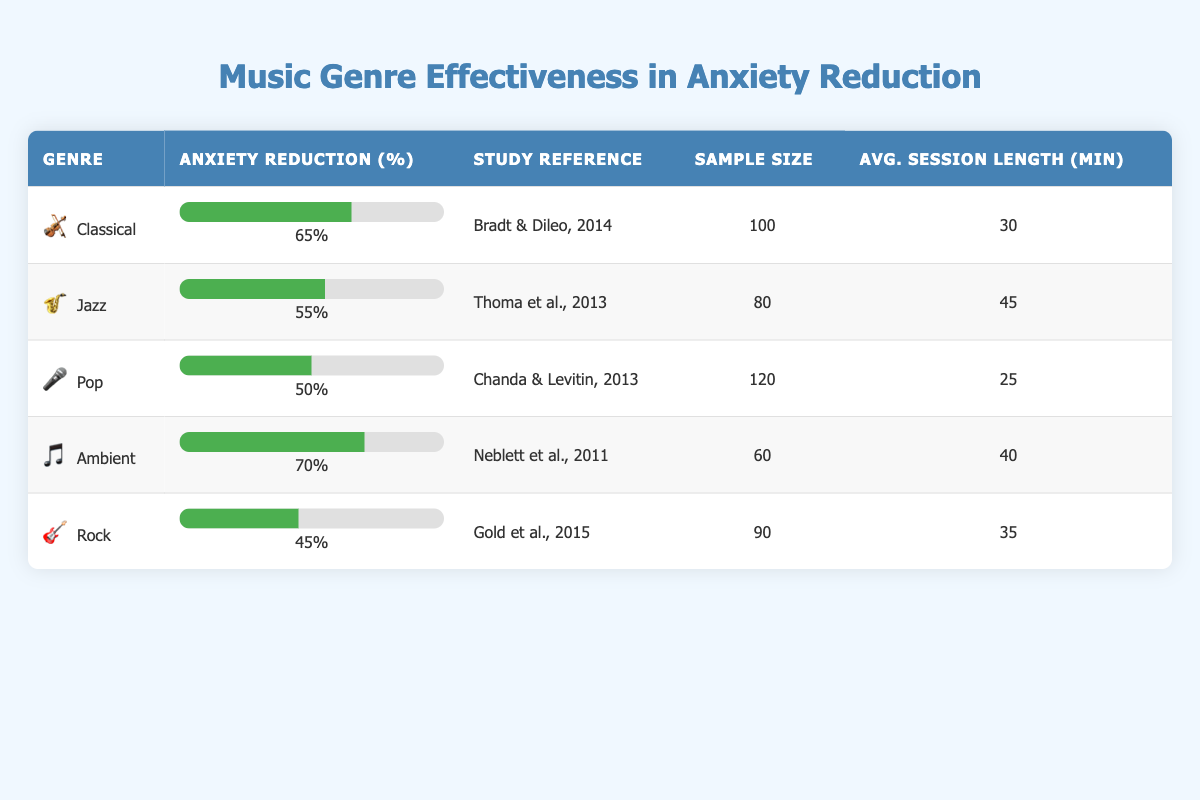What is the anxiety reduction percentage for Classical music? The table shows the anxiety reduction percentage for Classical music as 65%. Simply look for the row corresponding to Classical in the table.
Answer: 65% Which music genre has the highest anxiety reduction percentage? By comparing the anxiety reduction percentages in the table, Ambient music has the highest percentage at 70%. This is determined by scanning the percentages for all music genres listed.
Answer: Ambient What is the average session length for Jazz music therapy? The table indicates that the average session length for Jazz music therapy is 45 minutes. This value is found directly in the row for Jazz.
Answer: 45 minutes Is the sample size for Pop music therapy greater than that for Rock music therapy? The sample size for Pop music therapy is 120, while for Rock it's 90. Therefore, comparing these numbers shows that Pop's sample size is greater than Rock's.
Answer: Yes What is the average anxiety reduction percentage for the top two genres? The top two genres by anxiety reduction are Ambient (70%) and Classical (65%). The average is calculated by adding the two percentages (70 + 65) = 135, and then dividing by 2 to get 67.5. The steps are to identify the top two genres, sum their percentages, and divide by 2.
Answer: 67.5% Which genre has the lowest anxiety reduction percentage, and what is that percentage? From the data, Rock music has the lowest anxiety reduction percentage of 45%. This is identified by checking the percentages listed and finding the minimum value.
Answer: Rock, 45% How many more patients were involved in the Pop study compared to the Ambient study? The sample size for Pop is 120, and for Ambient, it is 60. The difference is calculated as 120 - 60 = 60, indicating there were 60 more patients in the Pop study. The answer involves subtracting the sample sizes.
Answer: 60 Is it true that Anxiety reduction percentage for Jazz is more than that for Rock? The anxiety reduction for Jazz is 55%, while for Rock it is 45%. Thus, confirming that 55 is greater than 45, shows that the statement is true. This is a straightforward comparison.
Answer: Yes What is the total sample size of all five music genres studied? The individual sample sizes from the table are 100 (Classical) + 80 (Jazz) + 120 (Pop) + 60 (Ambient) + 90 (Rock). Adding these values gives a total of 450. This involves adding all the sample sizes together.
Answer: 450 